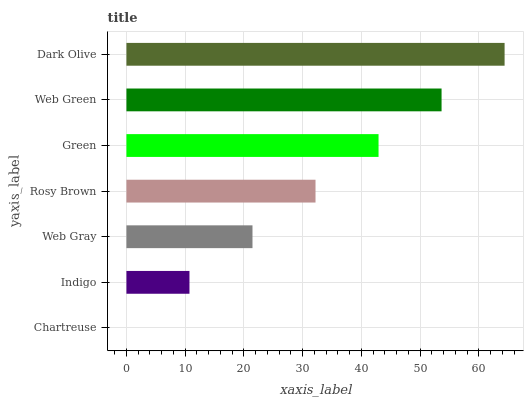Is Chartreuse the minimum?
Answer yes or no. Yes. Is Dark Olive the maximum?
Answer yes or no. Yes. Is Indigo the minimum?
Answer yes or no. No. Is Indigo the maximum?
Answer yes or no. No. Is Indigo greater than Chartreuse?
Answer yes or no. Yes. Is Chartreuse less than Indigo?
Answer yes or no. Yes. Is Chartreuse greater than Indigo?
Answer yes or no. No. Is Indigo less than Chartreuse?
Answer yes or no. No. Is Rosy Brown the high median?
Answer yes or no. Yes. Is Rosy Brown the low median?
Answer yes or no. Yes. Is Green the high median?
Answer yes or no. No. Is Web Gray the low median?
Answer yes or no. No. 